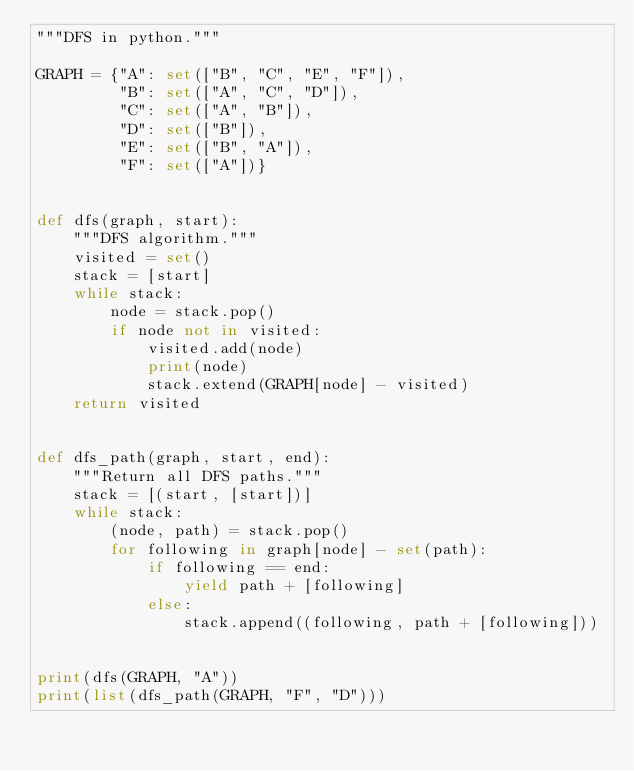<code> <loc_0><loc_0><loc_500><loc_500><_Python_>"""DFS in python."""

GRAPH = {"A": set(["B", "C", "E", "F"]),
         "B": set(["A", "C", "D"]),
         "C": set(["A", "B"]),
         "D": set(["B"]),
         "E": set(["B", "A"]),
         "F": set(["A"])}


def dfs(graph, start):
    """DFS algorithm."""
    visited = set()
    stack = [start]
    while stack:
        node = stack.pop()
        if node not in visited:
            visited.add(node)
            print(node)
            stack.extend(GRAPH[node] - visited)
    return visited


def dfs_path(graph, start, end):
    """Return all DFS paths."""
    stack = [(start, [start])]
    while stack:
        (node, path) = stack.pop()
        for following in graph[node] - set(path):
            if following == end:
                yield path + [following]
            else:
                stack.append((following, path + [following]))


print(dfs(GRAPH, "A"))
print(list(dfs_path(GRAPH, "F", "D")))
</code> 